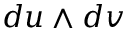<formula> <loc_0><loc_0><loc_500><loc_500>d u \wedge d v</formula> 